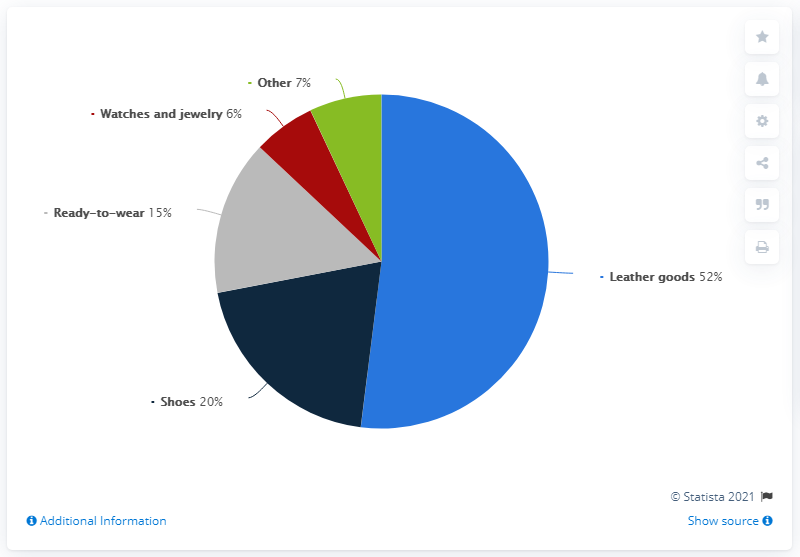Point out several critical features in this image. The product with the highest revenue share of the Kering Group worldwide in 2020 was leather goods. What are the remaining percentages of goods other than leather goods? 48.." can be converted to:

"Out of the total number of goods, 48% are made of materials other than leather. 